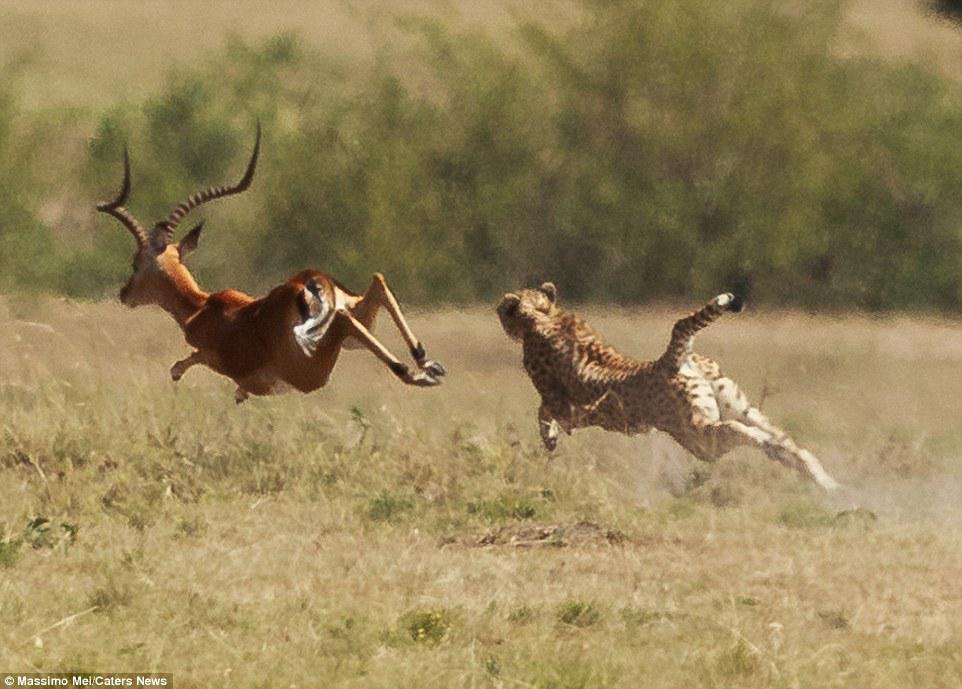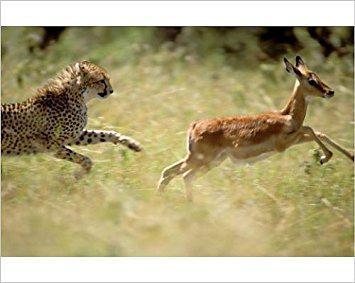The first image is the image on the left, the second image is the image on the right. Given the left and right images, does the statement "One leopard is chasing a young deer while another leopard will have antelope for the meal." hold true? Answer yes or no. Yes. 